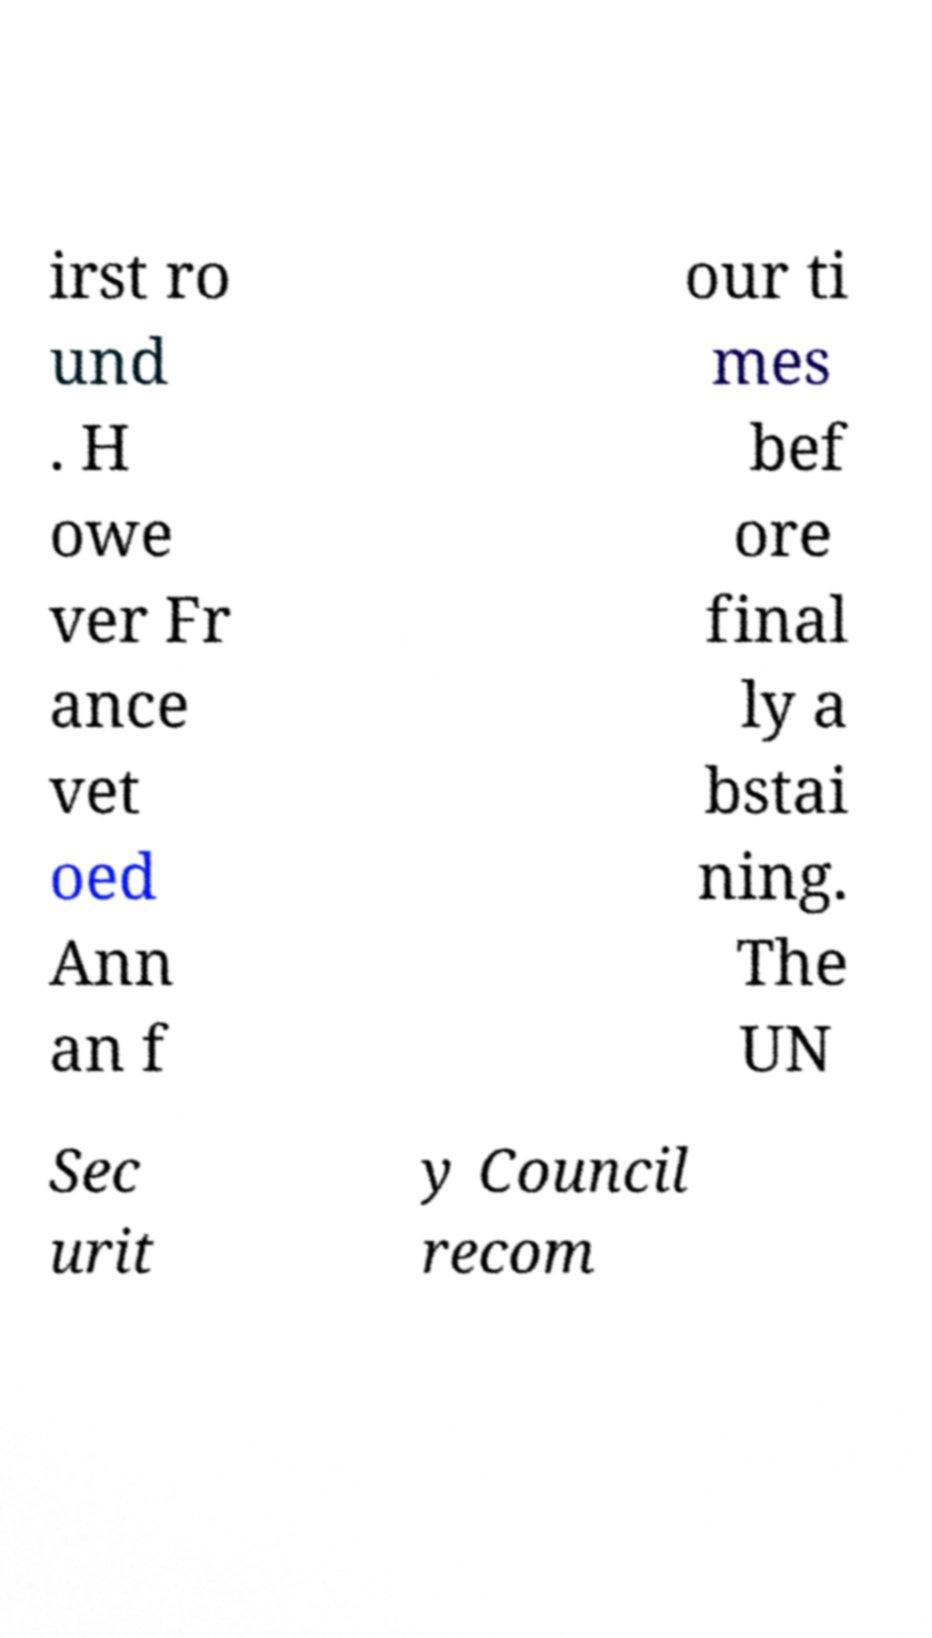Please identify and transcribe the text found in this image. irst ro und . H owe ver Fr ance vet oed Ann an f our ti mes bef ore final ly a bstai ning. The UN Sec urit y Council recom 